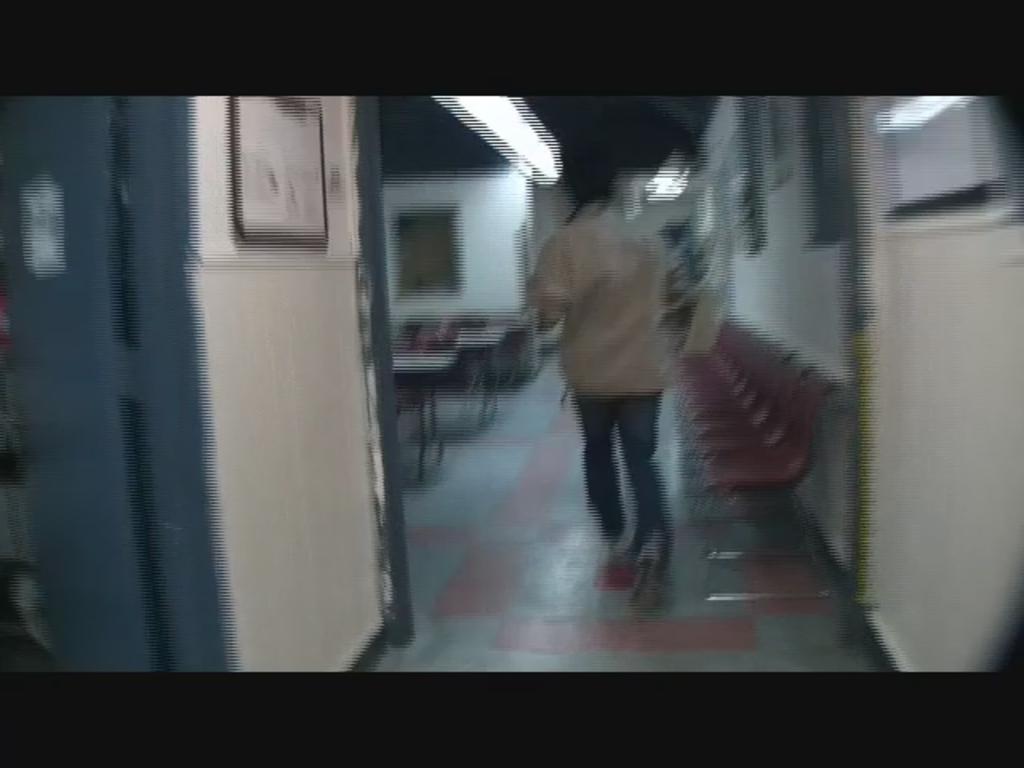Could you give a brief overview of what you see in this image? In this image we can see a person and there are chairs. We can see tables. On the left there is a door. In the background there is a wall and we can see lights. There is a frame placed on the wall. 